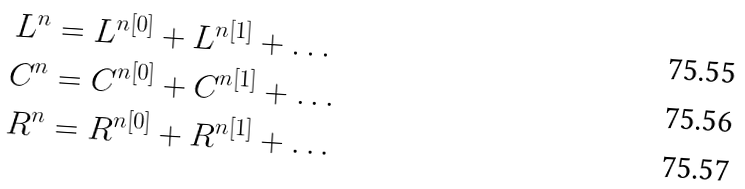Convert formula to latex. <formula><loc_0><loc_0><loc_500><loc_500>L ^ { n } & = L ^ { n [ 0 ] } + L ^ { n [ 1 ] } + \dots \\ C ^ { n } & = C ^ { n [ 0 ] } + C ^ { n [ 1 ] } + \dots \\ R ^ { n } & = R ^ { n [ 0 ] } + R ^ { n [ 1 ] } + \dots</formula> 